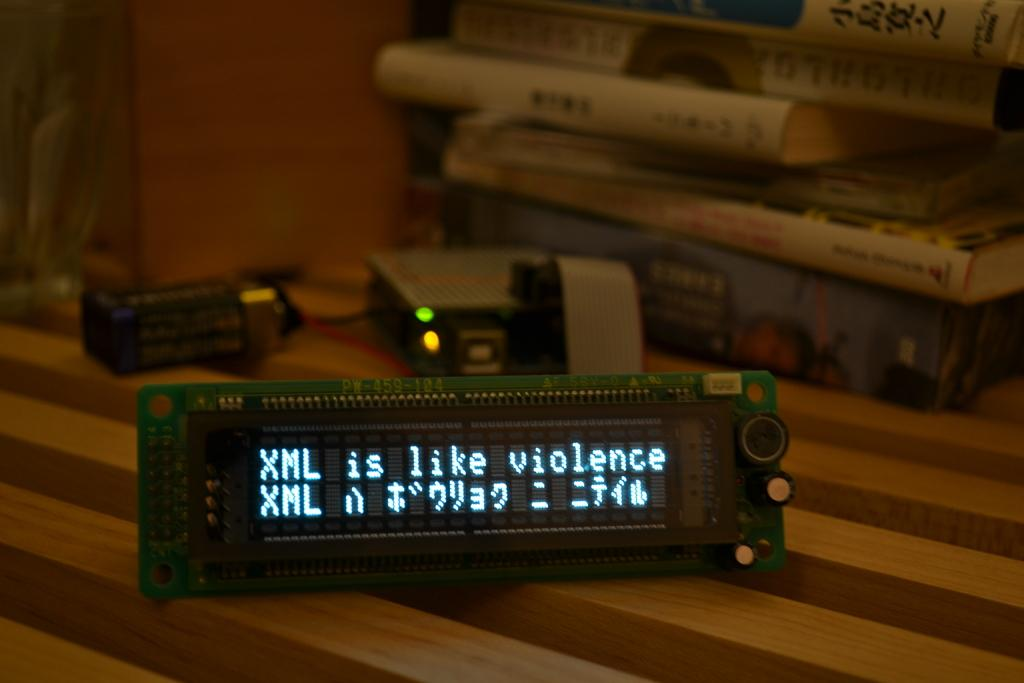Provide a one-sentence caption for the provided image. An electronic LED display says XML is like violence. 